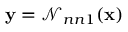Convert formula to latex. <formula><loc_0><loc_0><loc_500><loc_500>y = { \mathcal { N } _ { n n 1 } } ( x )</formula> 